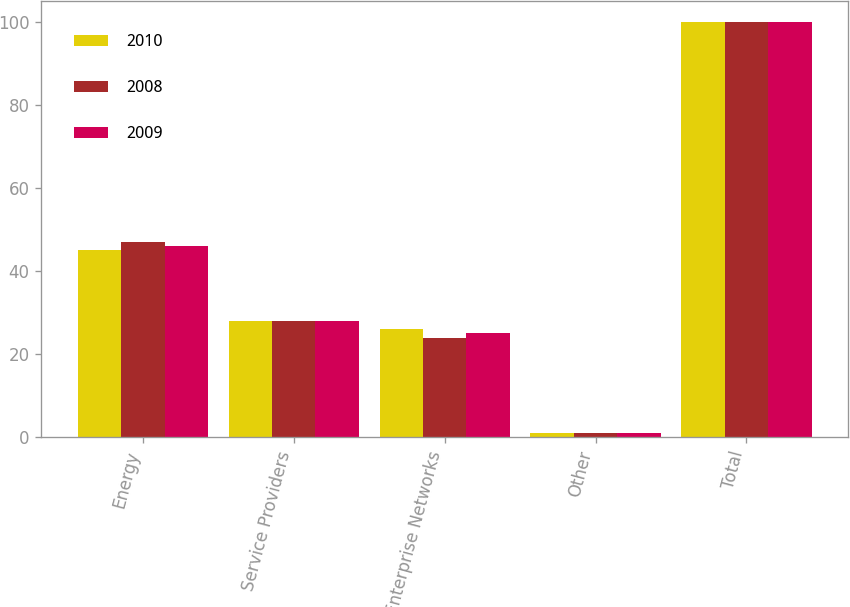<chart> <loc_0><loc_0><loc_500><loc_500><stacked_bar_chart><ecel><fcel>Energy<fcel>Service Providers<fcel>Enterprise Networks<fcel>Other<fcel>Total<nl><fcel>2010<fcel>45<fcel>28<fcel>26<fcel>1<fcel>100<nl><fcel>2008<fcel>47<fcel>28<fcel>24<fcel>1<fcel>100<nl><fcel>2009<fcel>46<fcel>28<fcel>25<fcel>1<fcel>100<nl></chart> 